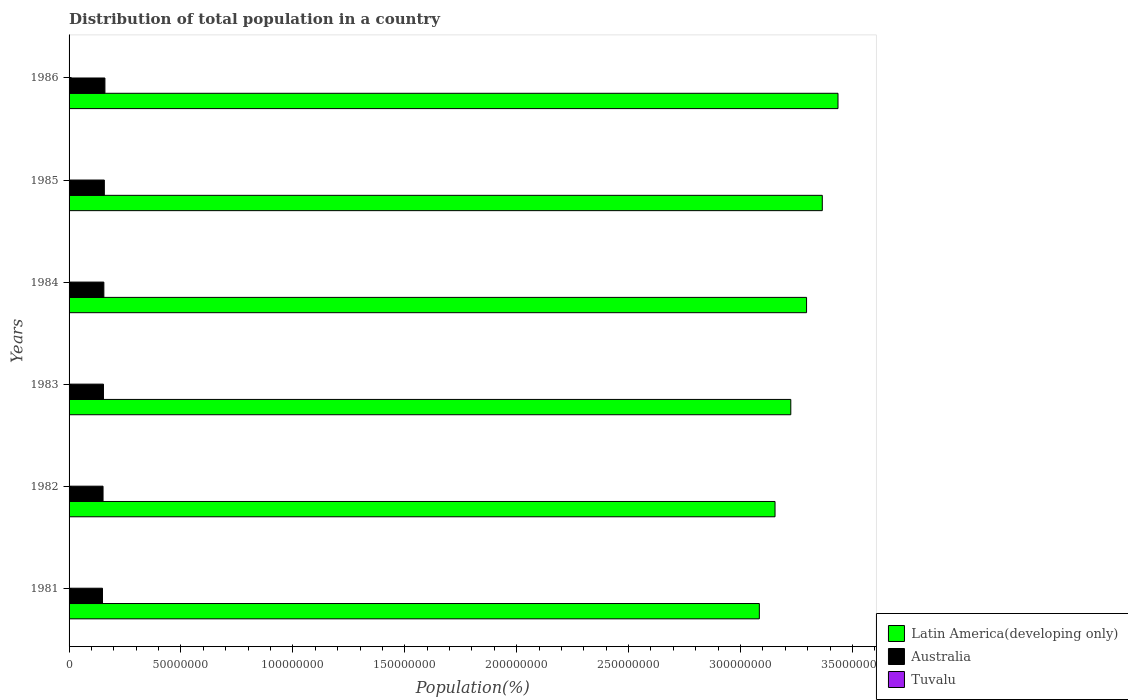How many different coloured bars are there?
Provide a short and direct response. 3. How many groups of bars are there?
Keep it short and to the point. 6. What is the label of the 2nd group of bars from the top?
Your answer should be compact. 1985. In how many cases, is the number of bars for a given year not equal to the number of legend labels?
Your answer should be compact. 0. What is the population of in Latin America(developing only) in 1984?
Offer a very short reply. 3.30e+08. Across all years, what is the maximum population of in Australia?
Give a very brief answer. 1.60e+07. Across all years, what is the minimum population of in Latin America(developing only)?
Provide a succinct answer. 3.08e+08. In which year was the population of in Latin America(developing only) maximum?
Provide a short and direct response. 1986. In which year was the population of in Latin America(developing only) minimum?
Offer a very short reply. 1981. What is the total population of in Tuvalu in the graph?
Provide a short and direct response. 5.08e+04. What is the difference between the population of in Latin America(developing only) in 1984 and that in 1986?
Offer a terse response. -1.40e+07. What is the difference between the population of in Tuvalu in 1981 and the population of in Australia in 1984?
Offer a very short reply. -1.55e+07. What is the average population of in Australia per year?
Provide a short and direct response. 1.55e+07. In the year 1981, what is the difference between the population of in Australia and population of in Latin America(developing only)?
Offer a terse response. -2.93e+08. What is the ratio of the population of in Australia in 1984 to that in 1986?
Give a very brief answer. 0.97. Is the population of in Latin America(developing only) in 1983 less than that in 1986?
Offer a very short reply. Yes. Is the difference between the population of in Australia in 1983 and 1986 greater than the difference between the population of in Latin America(developing only) in 1983 and 1986?
Keep it short and to the point. Yes. What is the difference between the highest and the second highest population of in Tuvalu?
Provide a succinct answer. 93. What is the difference between the highest and the lowest population of in Australia?
Provide a short and direct response. 1.09e+06. In how many years, is the population of in Latin America(developing only) greater than the average population of in Latin America(developing only) taken over all years?
Provide a short and direct response. 3. Is the sum of the population of in Tuvalu in 1983 and 1984 greater than the maximum population of in Australia across all years?
Your answer should be very brief. No. What does the 3rd bar from the bottom in 1984 represents?
Ensure brevity in your answer.  Tuvalu. Is it the case that in every year, the sum of the population of in Tuvalu and population of in Latin America(developing only) is greater than the population of in Australia?
Your response must be concise. Yes. How many bars are there?
Ensure brevity in your answer.  18. How many years are there in the graph?
Keep it short and to the point. 6. Are the values on the major ticks of X-axis written in scientific E-notation?
Give a very brief answer. No. How are the legend labels stacked?
Your answer should be compact. Vertical. What is the title of the graph?
Provide a succinct answer. Distribution of total population in a country. Does "East Asia (developing only)" appear as one of the legend labels in the graph?
Give a very brief answer. No. What is the label or title of the X-axis?
Ensure brevity in your answer.  Population(%). What is the label or title of the Y-axis?
Your answer should be compact. Years. What is the Population(%) in Latin America(developing only) in 1981?
Your answer should be very brief. 3.08e+08. What is the Population(%) of Australia in 1981?
Make the answer very short. 1.49e+07. What is the Population(%) in Tuvalu in 1981?
Provide a short and direct response. 8160. What is the Population(%) of Latin America(developing only) in 1982?
Your answer should be very brief. 3.15e+08. What is the Population(%) of Australia in 1982?
Offer a terse response. 1.52e+07. What is the Population(%) of Tuvalu in 1982?
Ensure brevity in your answer.  8284. What is the Population(%) in Latin America(developing only) in 1983?
Provide a short and direct response. 3.22e+08. What is the Population(%) in Australia in 1983?
Make the answer very short. 1.54e+07. What is the Population(%) in Tuvalu in 1983?
Keep it short and to the point. 8413. What is the Population(%) of Latin America(developing only) in 1984?
Give a very brief answer. 3.30e+08. What is the Population(%) in Australia in 1984?
Offer a terse response. 1.55e+07. What is the Population(%) of Tuvalu in 1984?
Provide a succinct answer. 8537. What is the Population(%) in Latin America(developing only) in 1985?
Your answer should be compact. 3.37e+08. What is the Population(%) of Australia in 1985?
Ensure brevity in your answer.  1.58e+07. What is the Population(%) in Tuvalu in 1985?
Your answer should be compact. 8648. What is the Population(%) in Latin America(developing only) in 1986?
Give a very brief answer. 3.44e+08. What is the Population(%) of Australia in 1986?
Your answer should be very brief. 1.60e+07. What is the Population(%) of Tuvalu in 1986?
Ensure brevity in your answer.  8741. Across all years, what is the maximum Population(%) in Latin America(developing only)?
Keep it short and to the point. 3.44e+08. Across all years, what is the maximum Population(%) of Australia?
Offer a very short reply. 1.60e+07. Across all years, what is the maximum Population(%) of Tuvalu?
Offer a terse response. 8741. Across all years, what is the minimum Population(%) in Latin America(developing only)?
Your answer should be very brief. 3.08e+08. Across all years, what is the minimum Population(%) in Australia?
Your answer should be very brief. 1.49e+07. Across all years, what is the minimum Population(%) in Tuvalu?
Give a very brief answer. 8160. What is the total Population(%) in Latin America(developing only) in the graph?
Ensure brevity in your answer.  1.96e+09. What is the total Population(%) of Australia in the graph?
Ensure brevity in your answer.  9.28e+07. What is the total Population(%) in Tuvalu in the graph?
Keep it short and to the point. 5.08e+04. What is the difference between the Population(%) in Latin America(developing only) in 1981 and that in 1982?
Provide a short and direct response. -7.01e+06. What is the difference between the Population(%) of Australia in 1981 and that in 1982?
Your answer should be very brief. -2.51e+05. What is the difference between the Population(%) in Tuvalu in 1981 and that in 1982?
Keep it short and to the point. -124. What is the difference between the Population(%) of Latin America(developing only) in 1981 and that in 1983?
Provide a short and direct response. -1.40e+07. What is the difference between the Population(%) in Australia in 1981 and that in 1983?
Offer a very short reply. -4.42e+05. What is the difference between the Population(%) in Tuvalu in 1981 and that in 1983?
Your answer should be compact. -253. What is the difference between the Population(%) of Latin America(developing only) in 1981 and that in 1984?
Keep it short and to the point. -2.11e+07. What is the difference between the Population(%) in Australia in 1981 and that in 1984?
Your response must be concise. -6.17e+05. What is the difference between the Population(%) of Tuvalu in 1981 and that in 1984?
Ensure brevity in your answer.  -377. What is the difference between the Population(%) in Latin America(developing only) in 1981 and that in 1985?
Provide a succinct answer. -2.81e+07. What is the difference between the Population(%) of Australia in 1981 and that in 1985?
Your response must be concise. -8.31e+05. What is the difference between the Population(%) of Tuvalu in 1981 and that in 1985?
Your answer should be compact. -488. What is the difference between the Population(%) in Latin America(developing only) in 1981 and that in 1986?
Make the answer very short. -3.51e+07. What is the difference between the Population(%) of Australia in 1981 and that in 1986?
Provide a succinct answer. -1.09e+06. What is the difference between the Population(%) in Tuvalu in 1981 and that in 1986?
Your answer should be very brief. -581. What is the difference between the Population(%) of Latin America(developing only) in 1982 and that in 1983?
Provide a succinct answer. -7.04e+06. What is the difference between the Population(%) in Australia in 1982 and that in 1983?
Your answer should be compact. -1.91e+05. What is the difference between the Population(%) of Tuvalu in 1982 and that in 1983?
Offer a terse response. -129. What is the difference between the Population(%) in Latin America(developing only) in 1982 and that in 1984?
Ensure brevity in your answer.  -1.41e+07. What is the difference between the Population(%) of Australia in 1982 and that in 1984?
Give a very brief answer. -3.66e+05. What is the difference between the Population(%) of Tuvalu in 1982 and that in 1984?
Make the answer very short. -253. What is the difference between the Population(%) in Latin America(developing only) in 1982 and that in 1985?
Provide a short and direct response. -2.11e+07. What is the difference between the Population(%) in Australia in 1982 and that in 1985?
Your response must be concise. -5.80e+05. What is the difference between the Population(%) in Tuvalu in 1982 and that in 1985?
Provide a succinct answer. -364. What is the difference between the Population(%) in Latin America(developing only) in 1982 and that in 1986?
Your answer should be very brief. -2.81e+07. What is the difference between the Population(%) of Australia in 1982 and that in 1986?
Provide a short and direct response. -8.40e+05. What is the difference between the Population(%) of Tuvalu in 1982 and that in 1986?
Provide a succinct answer. -457. What is the difference between the Population(%) of Latin America(developing only) in 1983 and that in 1984?
Your answer should be very brief. -7.05e+06. What is the difference between the Population(%) of Australia in 1983 and that in 1984?
Offer a very short reply. -1.75e+05. What is the difference between the Population(%) in Tuvalu in 1983 and that in 1984?
Offer a terse response. -124. What is the difference between the Population(%) in Latin America(developing only) in 1983 and that in 1985?
Your answer should be compact. -1.41e+07. What is the difference between the Population(%) in Australia in 1983 and that in 1985?
Make the answer very short. -3.89e+05. What is the difference between the Population(%) of Tuvalu in 1983 and that in 1985?
Your answer should be compact. -235. What is the difference between the Population(%) of Latin America(developing only) in 1983 and that in 1986?
Your answer should be compact. -2.11e+07. What is the difference between the Population(%) in Australia in 1983 and that in 1986?
Provide a short and direct response. -6.49e+05. What is the difference between the Population(%) in Tuvalu in 1983 and that in 1986?
Offer a terse response. -328. What is the difference between the Population(%) of Latin America(developing only) in 1984 and that in 1985?
Offer a very short reply. -7.03e+06. What is the difference between the Population(%) in Australia in 1984 and that in 1985?
Offer a very short reply. -2.14e+05. What is the difference between the Population(%) in Tuvalu in 1984 and that in 1985?
Make the answer very short. -111. What is the difference between the Population(%) of Latin America(developing only) in 1984 and that in 1986?
Offer a terse response. -1.40e+07. What is the difference between the Population(%) in Australia in 1984 and that in 1986?
Your answer should be very brief. -4.74e+05. What is the difference between the Population(%) in Tuvalu in 1984 and that in 1986?
Keep it short and to the point. -204. What is the difference between the Population(%) of Latin America(developing only) in 1985 and that in 1986?
Ensure brevity in your answer.  -7.01e+06. What is the difference between the Population(%) in Australia in 1985 and that in 1986?
Your response must be concise. -2.60e+05. What is the difference between the Population(%) of Tuvalu in 1985 and that in 1986?
Offer a terse response. -93. What is the difference between the Population(%) in Latin America(developing only) in 1981 and the Population(%) in Australia in 1982?
Provide a short and direct response. 2.93e+08. What is the difference between the Population(%) of Latin America(developing only) in 1981 and the Population(%) of Tuvalu in 1982?
Provide a short and direct response. 3.08e+08. What is the difference between the Population(%) of Australia in 1981 and the Population(%) of Tuvalu in 1982?
Keep it short and to the point. 1.49e+07. What is the difference between the Population(%) in Latin America(developing only) in 1981 and the Population(%) in Australia in 1983?
Provide a short and direct response. 2.93e+08. What is the difference between the Population(%) in Latin America(developing only) in 1981 and the Population(%) in Tuvalu in 1983?
Your response must be concise. 3.08e+08. What is the difference between the Population(%) in Australia in 1981 and the Population(%) in Tuvalu in 1983?
Keep it short and to the point. 1.49e+07. What is the difference between the Population(%) in Latin America(developing only) in 1981 and the Population(%) in Australia in 1984?
Provide a short and direct response. 2.93e+08. What is the difference between the Population(%) of Latin America(developing only) in 1981 and the Population(%) of Tuvalu in 1984?
Keep it short and to the point. 3.08e+08. What is the difference between the Population(%) of Australia in 1981 and the Population(%) of Tuvalu in 1984?
Provide a succinct answer. 1.49e+07. What is the difference between the Population(%) of Latin America(developing only) in 1981 and the Population(%) of Australia in 1985?
Provide a short and direct response. 2.93e+08. What is the difference between the Population(%) in Latin America(developing only) in 1981 and the Population(%) in Tuvalu in 1985?
Provide a succinct answer. 3.08e+08. What is the difference between the Population(%) in Australia in 1981 and the Population(%) in Tuvalu in 1985?
Make the answer very short. 1.49e+07. What is the difference between the Population(%) in Latin America(developing only) in 1981 and the Population(%) in Australia in 1986?
Provide a succinct answer. 2.92e+08. What is the difference between the Population(%) of Latin America(developing only) in 1981 and the Population(%) of Tuvalu in 1986?
Offer a terse response. 3.08e+08. What is the difference between the Population(%) of Australia in 1981 and the Population(%) of Tuvalu in 1986?
Provide a short and direct response. 1.49e+07. What is the difference between the Population(%) of Latin America(developing only) in 1982 and the Population(%) of Australia in 1983?
Offer a terse response. 3.00e+08. What is the difference between the Population(%) in Latin America(developing only) in 1982 and the Population(%) in Tuvalu in 1983?
Your answer should be compact. 3.15e+08. What is the difference between the Population(%) of Australia in 1982 and the Population(%) of Tuvalu in 1983?
Give a very brief answer. 1.52e+07. What is the difference between the Population(%) in Latin America(developing only) in 1982 and the Population(%) in Australia in 1984?
Make the answer very short. 3.00e+08. What is the difference between the Population(%) in Latin America(developing only) in 1982 and the Population(%) in Tuvalu in 1984?
Make the answer very short. 3.15e+08. What is the difference between the Population(%) of Australia in 1982 and the Population(%) of Tuvalu in 1984?
Provide a short and direct response. 1.52e+07. What is the difference between the Population(%) in Latin America(developing only) in 1982 and the Population(%) in Australia in 1985?
Provide a short and direct response. 3.00e+08. What is the difference between the Population(%) in Latin America(developing only) in 1982 and the Population(%) in Tuvalu in 1985?
Offer a very short reply. 3.15e+08. What is the difference between the Population(%) of Australia in 1982 and the Population(%) of Tuvalu in 1985?
Provide a succinct answer. 1.52e+07. What is the difference between the Population(%) in Latin America(developing only) in 1982 and the Population(%) in Australia in 1986?
Make the answer very short. 2.99e+08. What is the difference between the Population(%) in Latin America(developing only) in 1982 and the Population(%) in Tuvalu in 1986?
Give a very brief answer. 3.15e+08. What is the difference between the Population(%) of Australia in 1982 and the Population(%) of Tuvalu in 1986?
Give a very brief answer. 1.52e+07. What is the difference between the Population(%) in Latin America(developing only) in 1983 and the Population(%) in Australia in 1984?
Provide a short and direct response. 3.07e+08. What is the difference between the Population(%) of Latin America(developing only) in 1983 and the Population(%) of Tuvalu in 1984?
Your response must be concise. 3.22e+08. What is the difference between the Population(%) in Australia in 1983 and the Population(%) in Tuvalu in 1984?
Make the answer very short. 1.54e+07. What is the difference between the Population(%) in Latin America(developing only) in 1983 and the Population(%) in Australia in 1985?
Provide a succinct answer. 3.07e+08. What is the difference between the Population(%) in Latin America(developing only) in 1983 and the Population(%) in Tuvalu in 1985?
Offer a very short reply. 3.22e+08. What is the difference between the Population(%) of Australia in 1983 and the Population(%) of Tuvalu in 1985?
Your response must be concise. 1.54e+07. What is the difference between the Population(%) in Latin America(developing only) in 1983 and the Population(%) in Australia in 1986?
Your answer should be compact. 3.06e+08. What is the difference between the Population(%) of Latin America(developing only) in 1983 and the Population(%) of Tuvalu in 1986?
Keep it short and to the point. 3.22e+08. What is the difference between the Population(%) of Australia in 1983 and the Population(%) of Tuvalu in 1986?
Your answer should be very brief. 1.54e+07. What is the difference between the Population(%) in Latin America(developing only) in 1984 and the Population(%) in Australia in 1985?
Make the answer very short. 3.14e+08. What is the difference between the Population(%) of Latin America(developing only) in 1984 and the Population(%) of Tuvalu in 1985?
Your answer should be compact. 3.30e+08. What is the difference between the Population(%) in Australia in 1984 and the Population(%) in Tuvalu in 1985?
Your response must be concise. 1.55e+07. What is the difference between the Population(%) in Latin America(developing only) in 1984 and the Population(%) in Australia in 1986?
Your answer should be very brief. 3.14e+08. What is the difference between the Population(%) in Latin America(developing only) in 1984 and the Population(%) in Tuvalu in 1986?
Make the answer very short. 3.30e+08. What is the difference between the Population(%) of Australia in 1984 and the Population(%) of Tuvalu in 1986?
Offer a very short reply. 1.55e+07. What is the difference between the Population(%) of Latin America(developing only) in 1985 and the Population(%) of Australia in 1986?
Make the answer very short. 3.21e+08. What is the difference between the Population(%) of Latin America(developing only) in 1985 and the Population(%) of Tuvalu in 1986?
Give a very brief answer. 3.37e+08. What is the difference between the Population(%) of Australia in 1985 and the Population(%) of Tuvalu in 1986?
Offer a terse response. 1.57e+07. What is the average Population(%) of Latin America(developing only) per year?
Offer a terse response. 3.26e+08. What is the average Population(%) of Australia per year?
Provide a succinct answer. 1.55e+07. What is the average Population(%) of Tuvalu per year?
Your answer should be very brief. 8463.83. In the year 1981, what is the difference between the Population(%) of Latin America(developing only) and Population(%) of Australia?
Provide a short and direct response. 2.93e+08. In the year 1981, what is the difference between the Population(%) of Latin America(developing only) and Population(%) of Tuvalu?
Your response must be concise. 3.08e+08. In the year 1981, what is the difference between the Population(%) of Australia and Population(%) of Tuvalu?
Keep it short and to the point. 1.49e+07. In the year 1982, what is the difference between the Population(%) in Latin America(developing only) and Population(%) in Australia?
Provide a short and direct response. 3.00e+08. In the year 1982, what is the difference between the Population(%) in Latin America(developing only) and Population(%) in Tuvalu?
Ensure brevity in your answer.  3.15e+08. In the year 1982, what is the difference between the Population(%) of Australia and Population(%) of Tuvalu?
Give a very brief answer. 1.52e+07. In the year 1983, what is the difference between the Population(%) of Latin America(developing only) and Population(%) of Australia?
Your response must be concise. 3.07e+08. In the year 1983, what is the difference between the Population(%) of Latin America(developing only) and Population(%) of Tuvalu?
Offer a very short reply. 3.22e+08. In the year 1983, what is the difference between the Population(%) of Australia and Population(%) of Tuvalu?
Offer a very short reply. 1.54e+07. In the year 1984, what is the difference between the Population(%) of Latin America(developing only) and Population(%) of Australia?
Provide a short and direct response. 3.14e+08. In the year 1984, what is the difference between the Population(%) of Latin America(developing only) and Population(%) of Tuvalu?
Keep it short and to the point. 3.30e+08. In the year 1984, what is the difference between the Population(%) in Australia and Population(%) in Tuvalu?
Give a very brief answer. 1.55e+07. In the year 1985, what is the difference between the Population(%) of Latin America(developing only) and Population(%) of Australia?
Give a very brief answer. 3.21e+08. In the year 1985, what is the difference between the Population(%) in Latin America(developing only) and Population(%) in Tuvalu?
Offer a very short reply. 3.37e+08. In the year 1985, what is the difference between the Population(%) in Australia and Population(%) in Tuvalu?
Keep it short and to the point. 1.57e+07. In the year 1986, what is the difference between the Population(%) of Latin America(developing only) and Population(%) of Australia?
Your answer should be compact. 3.28e+08. In the year 1986, what is the difference between the Population(%) in Latin America(developing only) and Population(%) in Tuvalu?
Keep it short and to the point. 3.44e+08. In the year 1986, what is the difference between the Population(%) of Australia and Population(%) of Tuvalu?
Offer a very short reply. 1.60e+07. What is the ratio of the Population(%) of Latin America(developing only) in 1981 to that in 1982?
Give a very brief answer. 0.98. What is the ratio of the Population(%) of Australia in 1981 to that in 1982?
Ensure brevity in your answer.  0.98. What is the ratio of the Population(%) of Latin America(developing only) in 1981 to that in 1983?
Your answer should be very brief. 0.96. What is the ratio of the Population(%) of Australia in 1981 to that in 1983?
Offer a terse response. 0.97. What is the ratio of the Population(%) of Tuvalu in 1981 to that in 1983?
Keep it short and to the point. 0.97. What is the ratio of the Population(%) in Latin America(developing only) in 1981 to that in 1984?
Keep it short and to the point. 0.94. What is the ratio of the Population(%) in Australia in 1981 to that in 1984?
Provide a succinct answer. 0.96. What is the ratio of the Population(%) in Tuvalu in 1981 to that in 1984?
Offer a very short reply. 0.96. What is the ratio of the Population(%) of Latin America(developing only) in 1981 to that in 1985?
Your response must be concise. 0.92. What is the ratio of the Population(%) of Australia in 1981 to that in 1985?
Make the answer very short. 0.95. What is the ratio of the Population(%) in Tuvalu in 1981 to that in 1985?
Provide a succinct answer. 0.94. What is the ratio of the Population(%) of Latin America(developing only) in 1981 to that in 1986?
Keep it short and to the point. 0.9. What is the ratio of the Population(%) in Australia in 1981 to that in 1986?
Ensure brevity in your answer.  0.93. What is the ratio of the Population(%) of Tuvalu in 1981 to that in 1986?
Provide a succinct answer. 0.93. What is the ratio of the Population(%) of Latin America(developing only) in 1982 to that in 1983?
Make the answer very short. 0.98. What is the ratio of the Population(%) in Australia in 1982 to that in 1983?
Ensure brevity in your answer.  0.99. What is the ratio of the Population(%) in Tuvalu in 1982 to that in 1983?
Your response must be concise. 0.98. What is the ratio of the Population(%) in Latin America(developing only) in 1982 to that in 1984?
Offer a very short reply. 0.96. What is the ratio of the Population(%) in Australia in 1982 to that in 1984?
Your response must be concise. 0.98. What is the ratio of the Population(%) of Tuvalu in 1982 to that in 1984?
Give a very brief answer. 0.97. What is the ratio of the Population(%) of Latin America(developing only) in 1982 to that in 1985?
Provide a short and direct response. 0.94. What is the ratio of the Population(%) in Australia in 1982 to that in 1985?
Provide a short and direct response. 0.96. What is the ratio of the Population(%) in Tuvalu in 1982 to that in 1985?
Your answer should be compact. 0.96. What is the ratio of the Population(%) of Latin America(developing only) in 1982 to that in 1986?
Your response must be concise. 0.92. What is the ratio of the Population(%) in Australia in 1982 to that in 1986?
Keep it short and to the point. 0.95. What is the ratio of the Population(%) of Tuvalu in 1982 to that in 1986?
Ensure brevity in your answer.  0.95. What is the ratio of the Population(%) in Latin America(developing only) in 1983 to that in 1984?
Keep it short and to the point. 0.98. What is the ratio of the Population(%) in Australia in 1983 to that in 1984?
Keep it short and to the point. 0.99. What is the ratio of the Population(%) in Tuvalu in 1983 to that in 1984?
Provide a short and direct response. 0.99. What is the ratio of the Population(%) of Latin America(developing only) in 1983 to that in 1985?
Offer a terse response. 0.96. What is the ratio of the Population(%) of Australia in 1983 to that in 1985?
Ensure brevity in your answer.  0.98. What is the ratio of the Population(%) in Tuvalu in 1983 to that in 1985?
Offer a terse response. 0.97. What is the ratio of the Population(%) of Latin America(developing only) in 1983 to that in 1986?
Ensure brevity in your answer.  0.94. What is the ratio of the Population(%) of Australia in 1983 to that in 1986?
Ensure brevity in your answer.  0.96. What is the ratio of the Population(%) in Tuvalu in 1983 to that in 1986?
Your response must be concise. 0.96. What is the ratio of the Population(%) in Latin America(developing only) in 1984 to that in 1985?
Ensure brevity in your answer.  0.98. What is the ratio of the Population(%) of Australia in 1984 to that in 1985?
Your answer should be very brief. 0.99. What is the ratio of the Population(%) of Tuvalu in 1984 to that in 1985?
Your answer should be very brief. 0.99. What is the ratio of the Population(%) in Latin America(developing only) in 1984 to that in 1986?
Offer a very short reply. 0.96. What is the ratio of the Population(%) in Australia in 1984 to that in 1986?
Your answer should be compact. 0.97. What is the ratio of the Population(%) of Tuvalu in 1984 to that in 1986?
Make the answer very short. 0.98. What is the ratio of the Population(%) of Latin America(developing only) in 1985 to that in 1986?
Your answer should be compact. 0.98. What is the ratio of the Population(%) in Australia in 1985 to that in 1986?
Your response must be concise. 0.98. What is the difference between the highest and the second highest Population(%) in Latin America(developing only)?
Offer a very short reply. 7.01e+06. What is the difference between the highest and the second highest Population(%) in Australia?
Offer a very short reply. 2.60e+05. What is the difference between the highest and the second highest Population(%) of Tuvalu?
Your answer should be compact. 93. What is the difference between the highest and the lowest Population(%) of Latin America(developing only)?
Ensure brevity in your answer.  3.51e+07. What is the difference between the highest and the lowest Population(%) of Australia?
Your response must be concise. 1.09e+06. What is the difference between the highest and the lowest Population(%) in Tuvalu?
Your answer should be very brief. 581. 